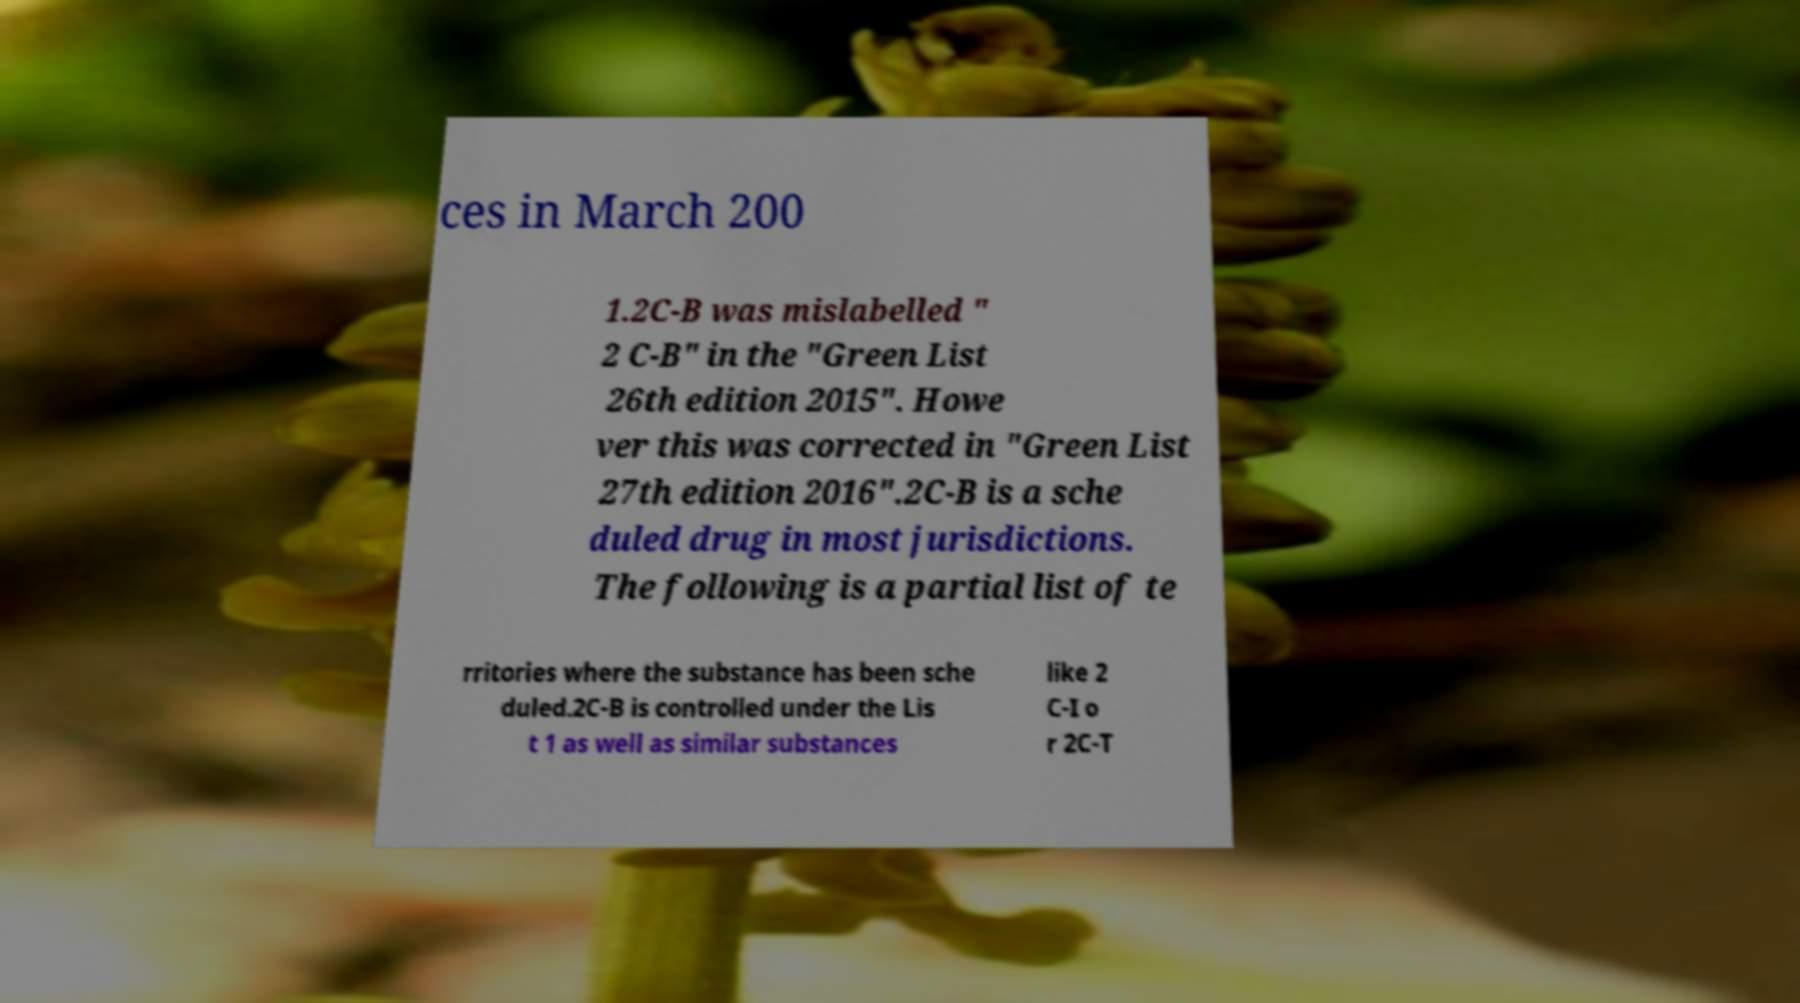Please identify and transcribe the text found in this image. ces in March 200 1.2C-B was mislabelled " 2 C-B" in the "Green List 26th edition 2015". Howe ver this was corrected in "Green List 27th edition 2016".2C-B is a sche duled drug in most jurisdictions. The following is a partial list of te rritories where the substance has been sche duled.2C-B is controlled under the Lis t 1 as well as similar substances like 2 C-I o r 2C-T 